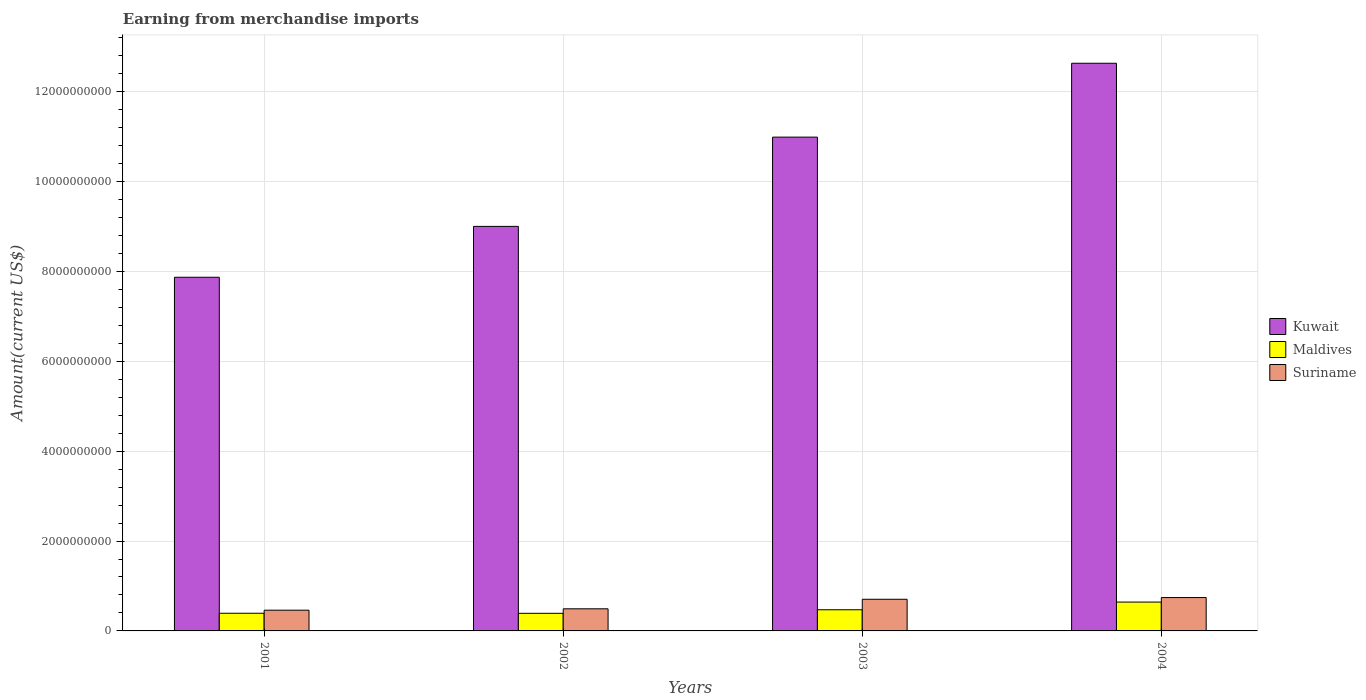How many groups of bars are there?
Ensure brevity in your answer.  4. Are the number of bars on each tick of the X-axis equal?
Your response must be concise. Yes. How many bars are there on the 1st tick from the left?
Ensure brevity in your answer.  3. How many bars are there on the 4th tick from the right?
Your answer should be compact. 3. What is the label of the 4th group of bars from the left?
Provide a succinct answer. 2004. In how many cases, is the number of bars for a given year not equal to the number of legend labels?
Your response must be concise. 0. What is the amount earned from merchandise imports in Kuwait in 2003?
Offer a very short reply. 1.10e+1. Across all years, what is the maximum amount earned from merchandise imports in Suriname?
Offer a very short reply. 7.42e+08. Across all years, what is the minimum amount earned from merchandise imports in Maldives?
Your answer should be very brief. 3.92e+08. In which year was the amount earned from merchandise imports in Maldives minimum?
Ensure brevity in your answer.  2002. What is the total amount earned from merchandise imports in Suriname in the graph?
Provide a short and direct response. 2.40e+09. What is the difference between the amount earned from merchandise imports in Maldives in 2001 and that in 2004?
Your answer should be very brief. -2.49e+08. What is the difference between the amount earned from merchandise imports in Kuwait in 2002 and the amount earned from merchandise imports in Maldives in 2004?
Ensure brevity in your answer.  8.36e+09. What is the average amount earned from merchandise imports in Kuwait per year?
Keep it short and to the point. 1.01e+1. In the year 2001, what is the difference between the amount earned from merchandise imports in Kuwait and amount earned from merchandise imports in Suriname?
Provide a succinct answer. 7.41e+09. In how many years, is the amount earned from merchandise imports in Kuwait greater than 2000000000 US$?
Provide a succinct answer. 4. What is the ratio of the amount earned from merchandise imports in Suriname in 2001 to that in 2002?
Make the answer very short. 0.94. What is the difference between the highest and the second highest amount earned from merchandise imports in Maldives?
Your answer should be compact. 1.71e+08. What is the difference between the highest and the lowest amount earned from merchandise imports in Kuwait?
Provide a succinct answer. 4.76e+09. Is the sum of the amount earned from merchandise imports in Suriname in 2001 and 2003 greater than the maximum amount earned from merchandise imports in Kuwait across all years?
Make the answer very short. No. What does the 2nd bar from the left in 2001 represents?
Offer a terse response. Maldives. What does the 3rd bar from the right in 2001 represents?
Your answer should be very brief. Kuwait. Is it the case that in every year, the sum of the amount earned from merchandise imports in Maldives and amount earned from merchandise imports in Kuwait is greater than the amount earned from merchandise imports in Suriname?
Ensure brevity in your answer.  Yes. How many years are there in the graph?
Keep it short and to the point. 4. Are the values on the major ticks of Y-axis written in scientific E-notation?
Offer a terse response. No. How many legend labels are there?
Your response must be concise. 3. How are the legend labels stacked?
Your response must be concise. Vertical. What is the title of the graph?
Keep it short and to the point. Earning from merchandise imports. What is the label or title of the X-axis?
Your response must be concise. Years. What is the label or title of the Y-axis?
Your answer should be compact. Amount(current US$). What is the Amount(current US$) of Kuwait in 2001?
Keep it short and to the point. 7.87e+09. What is the Amount(current US$) in Maldives in 2001?
Provide a succinct answer. 3.93e+08. What is the Amount(current US$) in Suriname in 2001?
Offer a terse response. 4.61e+08. What is the Amount(current US$) in Kuwait in 2002?
Keep it short and to the point. 9.00e+09. What is the Amount(current US$) of Maldives in 2002?
Offer a terse response. 3.92e+08. What is the Amount(current US$) of Suriname in 2002?
Your answer should be compact. 4.92e+08. What is the Amount(current US$) of Kuwait in 2003?
Your answer should be compact. 1.10e+1. What is the Amount(current US$) of Maldives in 2003?
Keep it short and to the point. 4.71e+08. What is the Amount(current US$) of Suriname in 2003?
Offer a very short reply. 7.04e+08. What is the Amount(current US$) of Kuwait in 2004?
Offer a terse response. 1.26e+1. What is the Amount(current US$) of Maldives in 2004?
Make the answer very short. 6.42e+08. What is the Amount(current US$) in Suriname in 2004?
Your answer should be compact. 7.42e+08. Across all years, what is the maximum Amount(current US$) of Kuwait?
Your answer should be very brief. 1.26e+1. Across all years, what is the maximum Amount(current US$) of Maldives?
Provide a short and direct response. 6.42e+08. Across all years, what is the maximum Amount(current US$) in Suriname?
Give a very brief answer. 7.42e+08. Across all years, what is the minimum Amount(current US$) in Kuwait?
Ensure brevity in your answer.  7.87e+09. Across all years, what is the minimum Amount(current US$) of Maldives?
Make the answer very short. 3.92e+08. Across all years, what is the minimum Amount(current US$) of Suriname?
Offer a terse response. 4.61e+08. What is the total Amount(current US$) of Kuwait in the graph?
Give a very brief answer. 4.05e+1. What is the total Amount(current US$) of Maldives in the graph?
Offer a very short reply. 1.90e+09. What is the total Amount(current US$) of Suriname in the graph?
Give a very brief answer. 2.40e+09. What is the difference between the Amount(current US$) of Kuwait in 2001 and that in 2002?
Your answer should be compact. -1.13e+09. What is the difference between the Amount(current US$) of Maldives in 2001 and that in 2002?
Keep it short and to the point. 1.28e+06. What is the difference between the Amount(current US$) in Suriname in 2001 and that in 2002?
Keep it short and to the point. -3.10e+07. What is the difference between the Amount(current US$) of Kuwait in 2001 and that in 2003?
Ensure brevity in your answer.  -3.12e+09. What is the difference between the Amount(current US$) in Maldives in 2001 and that in 2003?
Provide a succinct answer. -7.78e+07. What is the difference between the Amount(current US$) in Suriname in 2001 and that in 2003?
Your answer should be compact. -2.43e+08. What is the difference between the Amount(current US$) in Kuwait in 2001 and that in 2004?
Your response must be concise. -4.76e+09. What is the difference between the Amount(current US$) of Maldives in 2001 and that in 2004?
Your answer should be compact. -2.49e+08. What is the difference between the Amount(current US$) of Suriname in 2001 and that in 2004?
Provide a succinct answer. -2.81e+08. What is the difference between the Amount(current US$) of Kuwait in 2002 and that in 2003?
Make the answer very short. -1.99e+09. What is the difference between the Amount(current US$) in Maldives in 2002 and that in 2003?
Your response must be concise. -7.91e+07. What is the difference between the Amount(current US$) in Suriname in 2002 and that in 2003?
Offer a terse response. -2.12e+08. What is the difference between the Amount(current US$) in Kuwait in 2002 and that in 2004?
Provide a short and direct response. -3.63e+09. What is the difference between the Amount(current US$) of Maldives in 2002 and that in 2004?
Your response must be concise. -2.50e+08. What is the difference between the Amount(current US$) of Suriname in 2002 and that in 2004?
Keep it short and to the point. -2.50e+08. What is the difference between the Amount(current US$) of Kuwait in 2003 and that in 2004?
Your answer should be compact. -1.64e+09. What is the difference between the Amount(current US$) in Maldives in 2003 and that in 2004?
Make the answer very short. -1.71e+08. What is the difference between the Amount(current US$) in Suriname in 2003 and that in 2004?
Provide a succinct answer. -3.85e+07. What is the difference between the Amount(current US$) of Kuwait in 2001 and the Amount(current US$) of Maldives in 2002?
Offer a very short reply. 7.48e+09. What is the difference between the Amount(current US$) in Kuwait in 2001 and the Amount(current US$) in Suriname in 2002?
Ensure brevity in your answer.  7.38e+09. What is the difference between the Amount(current US$) of Maldives in 2001 and the Amount(current US$) of Suriname in 2002?
Provide a short and direct response. -9.90e+07. What is the difference between the Amount(current US$) of Kuwait in 2001 and the Amount(current US$) of Maldives in 2003?
Give a very brief answer. 7.40e+09. What is the difference between the Amount(current US$) in Kuwait in 2001 and the Amount(current US$) in Suriname in 2003?
Provide a succinct answer. 7.16e+09. What is the difference between the Amount(current US$) in Maldives in 2001 and the Amount(current US$) in Suriname in 2003?
Give a very brief answer. -3.11e+08. What is the difference between the Amount(current US$) of Kuwait in 2001 and the Amount(current US$) of Maldives in 2004?
Provide a short and direct response. 7.23e+09. What is the difference between the Amount(current US$) in Kuwait in 2001 and the Amount(current US$) in Suriname in 2004?
Provide a succinct answer. 7.13e+09. What is the difference between the Amount(current US$) in Maldives in 2001 and the Amount(current US$) in Suriname in 2004?
Your response must be concise. -3.49e+08. What is the difference between the Amount(current US$) of Kuwait in 2002 and the Amount(current US$) of Maldives in 2003?
Provide a short and direct response. 8.53e+09. What is the difference between the Amount(current US$) of Kuwait in 2002 and the Amount(current US$) of Suriname in 2003?
Your response must be concise. 8.30e+09. What is the difference between the Amount(current US$) of Maldives in 2002 and the Amount(current US$) of Suriname in 2003?
Keep it short and to the point. -3.12e+08. What is the difference between the Amount(current US$) of Kuwait in 2002 and the Amount(current US$) of Maldives in 2004?
Ensure brevity in your answer.  8.36e+09. What is the difference between the Amount(current US$) of Kuwait in 2002 and the Amount(current US$) of Suriname in 2004?
Offer a terse response. 8.26e+09. What is the difference between the Amount(current US$) in Maldives in 2002 and the Amount(current US$) in Suriname in 2004?
Your answer should be compact. -3.51e+08. What is the difference between the Amount(current US$) in Kuwait in 2003 and the Amount(current US$) in Maldives in 2004?
Ensure brevity in your answer.  1.03e+1. What is the difference between the Amount(current US$) in Kuwait in 2003 and the Amount(current US$) in Suriname in 2004?
Your answer should be very brief. 1.02e+1. What is the difference between the Amount(current US$) in Maldives in 2003 and the Amount(current US$) in Suriname in 2004?
Offer a terse response. -2.72e+08. What is the average Amount(current US$) in Kuwait per year?
Your answer should be very brief. 1.01e+1. What is the average Amount(current US$) of Maldives per year?
Your answer should be compact. 4.74e+08. What is the average Amount(current US$) in Suriname per year?
Your response must be concise. 6.00e+08. In the year 2001, what is the difference between the Amount(current US$) in Kuwait and Amount(current US$) in Maldives?
Make the answer very short. 7.48e+09. In the year 2001, what is the difference between the Amount(current US$) in Kuwait and Amount(current US$) in Suriname?
Keep it short and to the point. 7.41e+09. In the year 2001, what is the difference between the Amount(current US$) of Maldives and Amount(current US$) of Suriname?
Offer a very short reply. -6.80e+07. In the year 2002, what is the difference between the Amount(current US$) in Kuwait and Amount(current US$) in Maldives?
Keep it short and to the point. 8.61e+09. In the year 2002, what is the difference between the Amount(current US$) of Kuwait and Amount(current US$) of Suriname?
Your answer should be compact. 8.51e+09. In the year 2002, what is the difference between the Amount(current US$) of Maldives and Amount(current US$) of Suriname?
Your response must be concise. -1.00e+08. In the year 2003, what is the difference between the Amount(current US$) of Kuwait and Amount(current US$) of Maldives?
Offer a terse response. 1.05e+1. In the year 2003, what is the difference between the Amount(current US$) of Kuwait and Amount(current US$) of Suriname?
Your answer should be very brief. 1.03e+1. In the year 2003, what is the difference between the Amount(current US$) of Maldives and Amount(current US$) of Suriname?
Your answer should be compact. -2.33e+08. In the year 2004, what is the difference between the Amount(current US$) of Kuwait and Amount(current US$) of Maldives?
Make the answer very short. 1.20e+1. In the year 2004, what is the difference between the Amount(current US$) of Kuwait and Amount(current US$) of Suriname?
Your response must be concise. 1.19e+1. In the year 2004, what is the difference between the Amount(current US$) in Maldives and Amount(current US$) in Suriname?
Your answer should be compact. -1.01e+08. What is the ratio of the Amount(current US$) in Kuwait in 2001 to that in 2002?
Your answer should be compact. 0.87. What is the ratio of the Amount(current US$) of Suriname in 2001 to that in 2002?
Offer a terse response. 0.94. What is the ratio of the Amount(current US$) of Kuwait in 2001 to that in 2003?
Offer a terse response. 0.72. What is the ratio of the Amount(current US$) of Maldives in 2001 to that in 2003?
Your answer should be compact. 0.83. What is the ratio of the Amount(current US$) in Suriname in 2001 to that in 2003?
Provide a succinct answer. 0.65. What is the ratio of the Amount(current US$) in Kuwait in 2001 to that in 2004?
Make the answer very short. 0.62. What is the ratio of the Amount(current US$) in Maldives in 2001 to that in 2004?
Your answer should be compact. 0.61. What is the ratio of the Amount(current US$) in Suriname in 2001 to that in 2004?
Your answer should be compact. 0.62. What is the ratio of the Amount(current US$) of Kuwait in 2002 to that in 2003?
Offer a very short reply. 0.82. What is the ratio of the Amount(current US$) in Maldives in 2002 to that in 2003?
Your answer should be compact. 0.83. What is the ratio of the Amount(current US$) in Suriname in 2002 to that in 2003?
Offer a terse response. 0.7. What is the ratio of the Amount(current US$) in Kuwait in 2002 to that in 2004?
Offer a terse response. 0.71. What is the ratio of the Amount(current US$) of Maldives in 2002 to that in 2004?
Provide a short and direct response. 0.61. What is the ratio of the Amount(current US$) in Suriname in 2002 to that in 2004?
Provide a succinct answer. 0.66. What is the ratio of the Amount(current US$) in Kuwait in 2003 to that in 2004?
Ensure brevity in your answer.  0.87. What is the ratio of the Amount(current US$) in Maldives in 2003 to that in 2004?
Offer a terse response. 0.73. What is the ratio of the Amount(current US$) of Suriname in 2003 to that in 2004?
Provide a short and direct response. 0.95. What is the difference between the highest and the second highest Amount(current US$) in Kuwait?
Provide a short and direct response. 1.64e+09. What is the difference between the highest and the second highest Amount(current US$) of Maldives?
Your answer should be very brief. 1.71e+08. What is the difference between the highest and the second highest Amount(current US$) in Suriname?
Your response must be concise. 3.85e+07. What is the difference between the highest and the lowest Amount(current US$) of Kuwait?
Offer a terse response. 4.76e+09. What is the difference between the highest and the lowest Amount(current US$) in Maldives?
Offer a terse response. 2.50e+08. What is the difference between the highest and the lowest Amount(current US$) of Suriname?
Ensure brevity in your answer.  2.81e+08. 